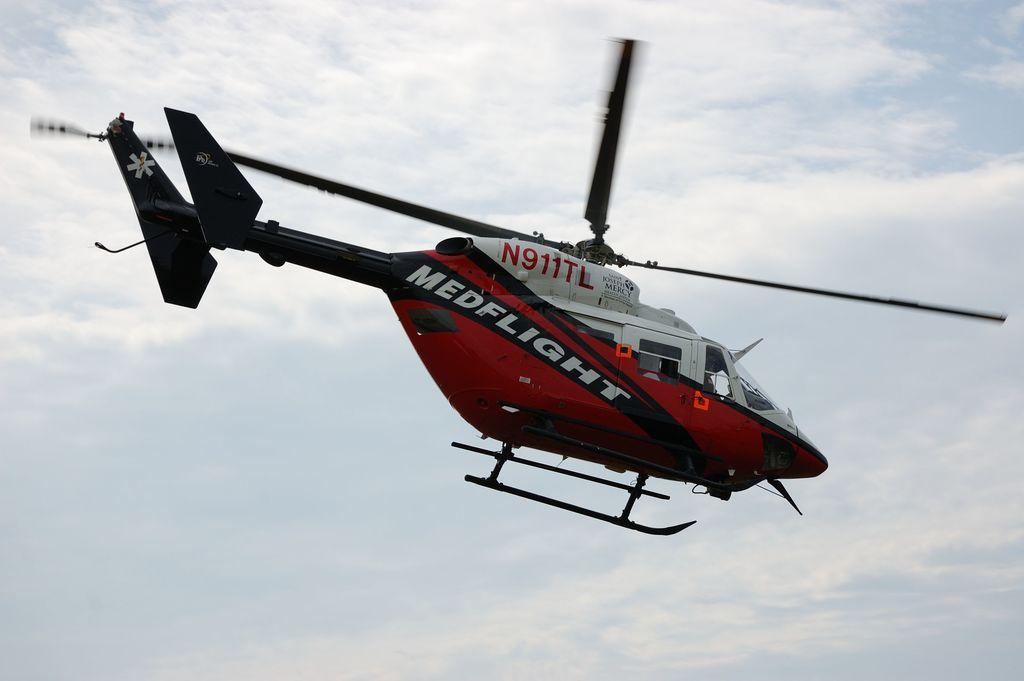<image>
Share a concise interpretation of the image provided. A Medflight flies through the air on a sunny day. 